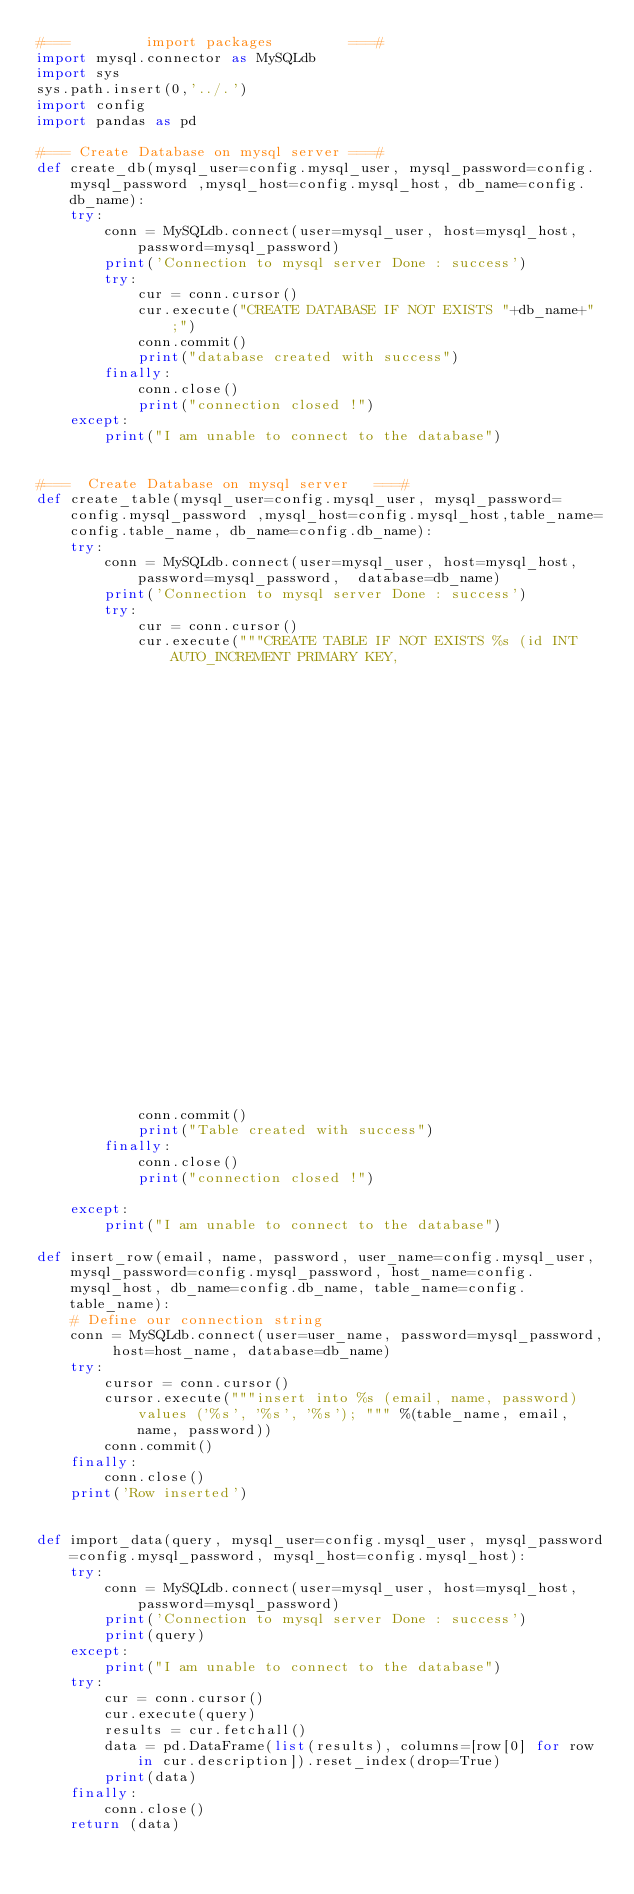<code> <loc_0><loc_0><loc_500><loc_500><_Python_>#===         import packages         ===#
import mysql.connector as MySQLdb
import sys
sys.path.insert(0,'../.')
import config
import pandas as pd

#=== Create Database on mysql server ===#
def create_db(mysql_user=config.mysql_user, mysql_password=config.mysql_password ,mysql_host=config.mysql_host, db_name=config.db_name):
    try:
        conn = MySQLdb.connect(user=mysql_user, host=mysql_host, password=mysql_password)
        print('Connection to mysql server Done : success')
        try:
            cur = conn.cursor()
            cur.execute("CREATE DATABASE IF NOT EXISTS "+db_name+" ;")
            conn.commit()
            print("database created with success")
        finally:
            conn.close()
            print("connection closed !")
    except:
        print("I am unable to connect to the database")


#===  Create Database on mysql server   ===#
def create_table(mysql_user=config.mysql_user, mysql_password=config.mysql_password ,mysql_host=config.mysql_host,table_name=config.table_name, db_name=config.db_name):
    try:
        conn = MySQLdb.connect(user=mysql_user, host=mysql_host, password=mysql_password,  database=db_name)
        print('Connection to mysql server Done : success')
        try:
            cur = conn.cursor()
            cur.execute("""CREATE TABLE IF NOT EXISTS %s (id INT AUTO_INCREMENT PRIMARY KEY,
                                                                              email varchar(250), 
                                                                              name varchar(250),
                                                                              password varchar(250) 
                                                                              );""" %(table_name))
            conn.commit()
            print("Table created with success")
        finally:
            conn.close()
            print("connection closed !")

    except:
        print("I am unable to connect to the database")

def insert_row(email, name, password, user_name=config.mysql_user, mysql_password=config.mysql_password, host_name=config.mysql_host, db_name=config.db_name, table_name=config.table_name):
    # Define our connection string
    conn = MySQLdb.connect(user=user_name, password=mysql_password, host=host_name, database=db_name)
    try:
        cursor = conn.cursor()
        cursor.execute("""insert into %s (email, name, password) values ('%s', '%s', '%s'); """ %(table_name, email, name, password))
        conn.commit()
    finally:
        conn.close()
    print('Row inserted')


def import_data(query, mysql_user=config.mysql_user, mysql_password=config.mysql_password, mysql_host=config.mysql_host):
    try:
        conn = MySQLdb.connect(user=mysql_user, host=mysql_host, password=mysql_password)
        print('Connection to mysql server Done : success')
        print(query)
    except:
        print("I am unable to connect to the database")
    try:
        cur = conn.cursor()
        cur.execute(query)
        results = cur.fetchall()
        data = pd.DataFrame(list(results), columns=[row[0] for row in cur.description]).reset_index(drop=True)
        print(data)
    finally:
        conn.close()
    return (data)
</code> 